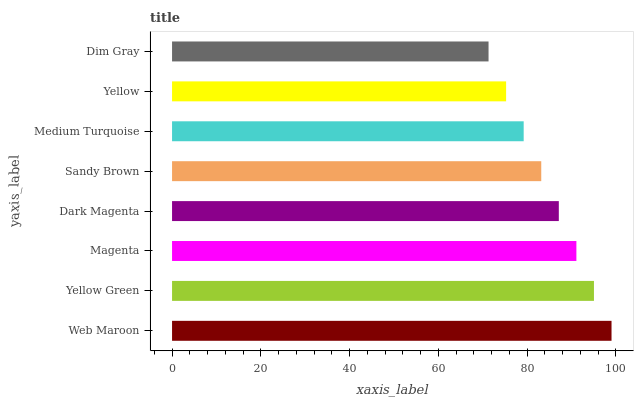Is Dim Gray the minimum?
Answer yes or no. Yes. Is Web Maroon the maximum?
Answer yes or no. Yes. Is Yellow Green the minimum?
Answer yes or no. No. Is Yellow Green the maximum?
Answer yes or no. No. Is Web Maroon greater than Yellow Green?
Answer yes or no. Yes. Is Yellow Green less than Web Maroon?
Answer yes or no. Yes. Is Yellow Green greater than Web Maroon?
Answer yes or no. No. Is Web Maroon less than Yellow Green?
Answer yes or no. No. Is Dark Magenta the high median?
Answer yes or no. Yes. Is Sandy Brown the low median?
Answer yes or no. Yes. Is Yellow Green the high median?
Answer yes or no. No. Is Yellow the low median?
Answer yes or no. No. 